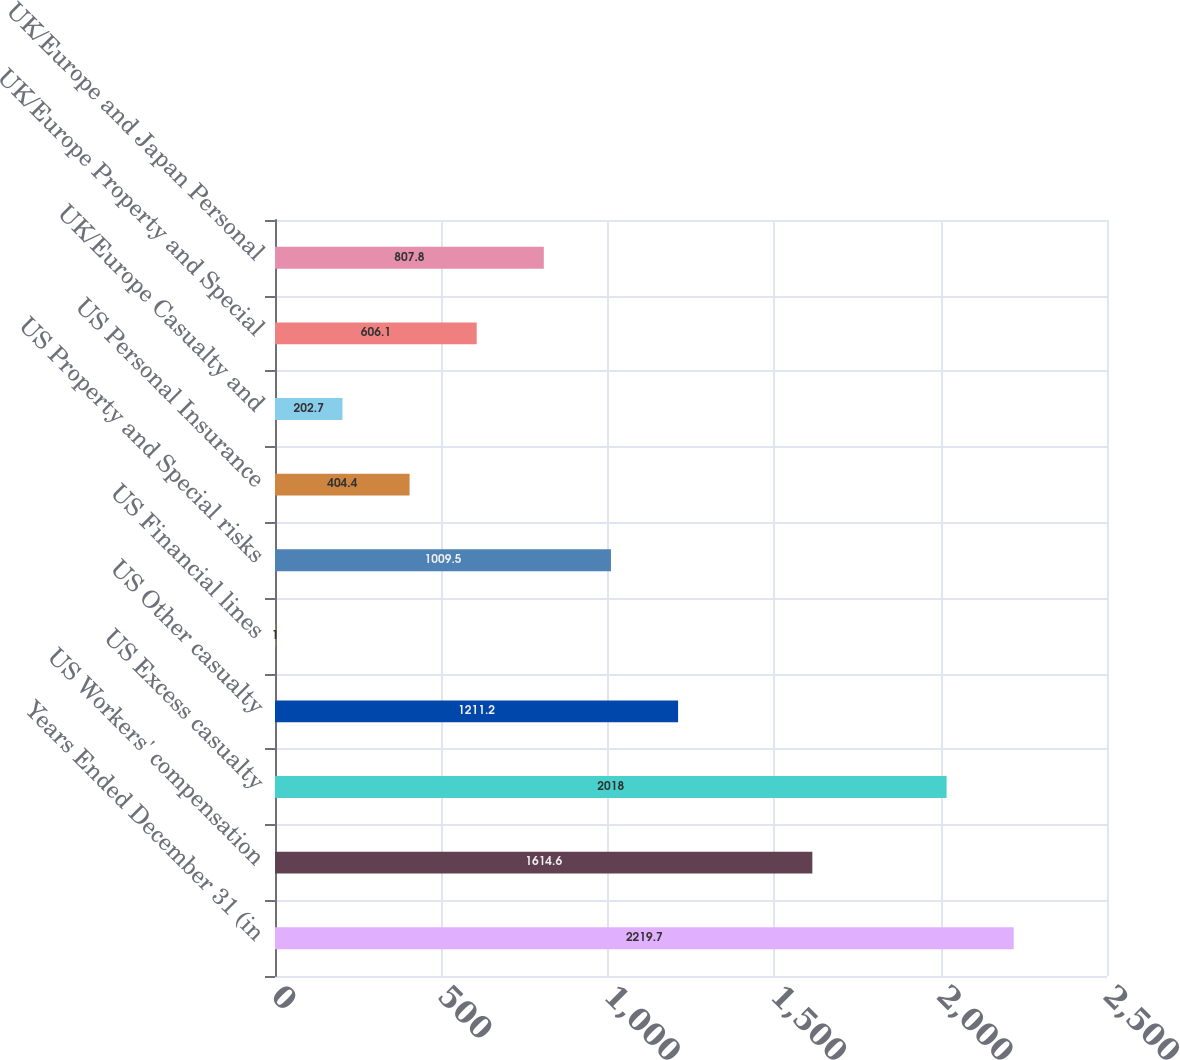Convert chart to OTSL. <chart><loc_0><loc_0><loc_500><loc_500><bar_chart><fcel>Years Ended December 31 (in<fcel>US Workers' compensation<fcel>US Excess casualty<fcel>US Other casualty<fcel>US Financial lines<fcel>US Property and Special risks<fcel>US Personal Insurance<fcel>UK/Europe Casualty and<fcel>UK/Europe Property and Special<fcel>UK/Europe and Japan Personal<nl><fcel>2219.7<fcel>1614.6<fcel>2018<fcel>1211.2<fcel>1<fcel>1009.5<fcel>404.4<fcel>202.7<fcel>606.1<fcel>807.8<nl></chart> 